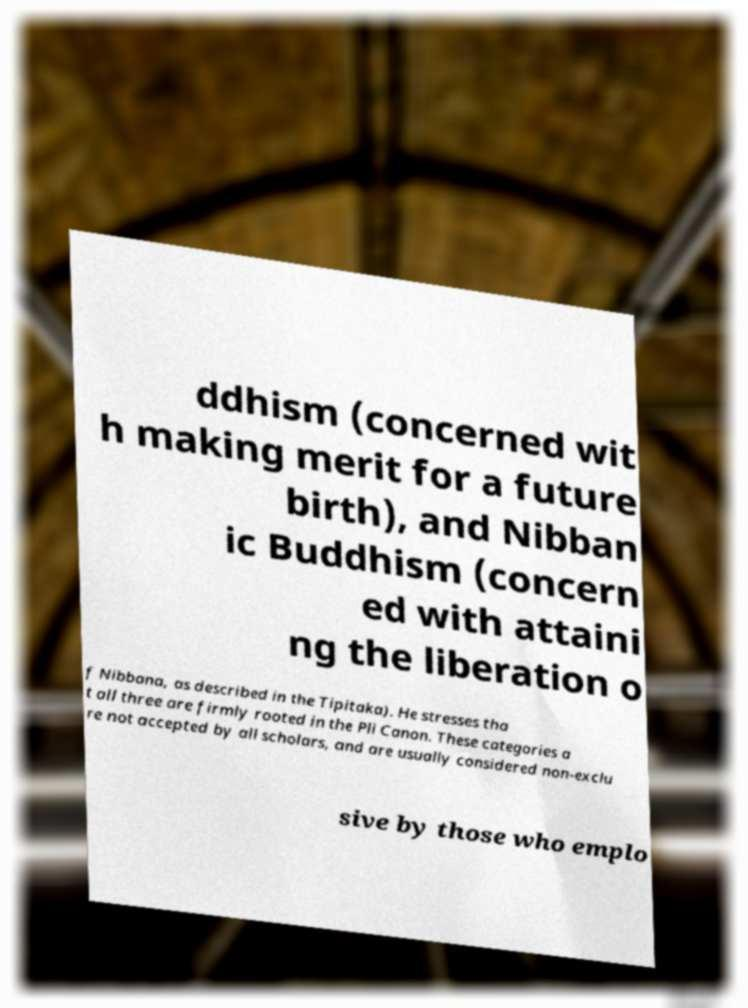I need the written content from this picture converted into text. Can you do that? ddhism (concerned wit h making merit for a future birth), and Nibban ic Buddhism (concern ed with attaini ng the liberation o f Nibbana, as described in the Tipitaka). He stresses tha t all three are firmly rooted in the Pli Canon. These categories a re not accepted by all scholars, and are usually considered non-exclu sive by those who emplo 